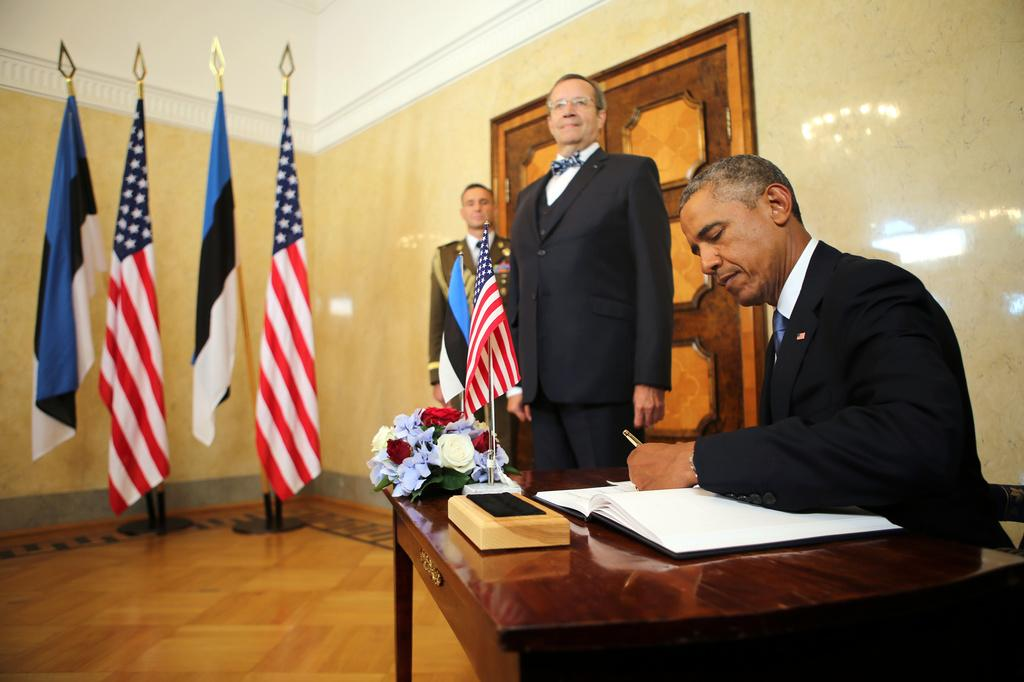How many men are present in the image? There are three men in the image. What are the positions of the men in the image? Two of the men are standing, and one of the men is sitting. What objects can be seen in the image besides the men? There is a book, a flower, and flags in the image. What time of day is it in the image, considering the afternoon? The provided facts do not mention the time of day, so it cannot be determined if it is afternoon or not. 